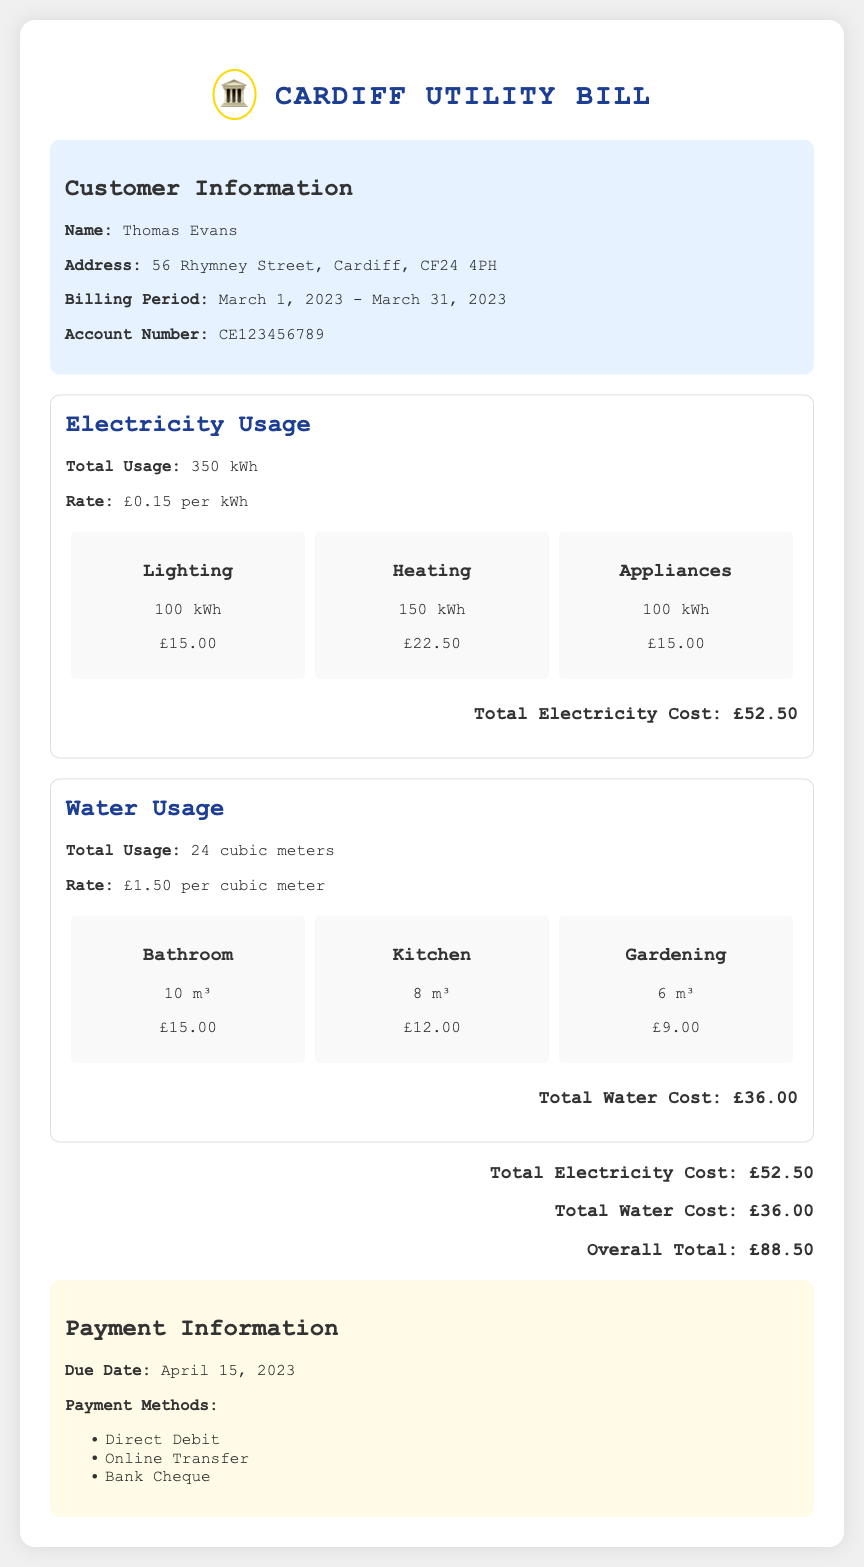What is the name of the customer? The document states the customer's name is Thomas Evans.
Answer: Thomas Evans What is the address of the residence? The address provided in the document is essential for billing purposes; it mentions 56 Rhymney Street, Cardiff, CF24 4PH.
Answer: 56 Rhymney Street, Cardiff, CF24 4PH What is the total electricity usage for March 2023? The total electricity usage is directly mentioned in the electricity section of the document as 350 kWh.
Answer: 350 kWh What is the total water usage? The document lists the total water usage, stating it's 24 cubic meters.
Answer: 24 cubic meters What is the due date for the payment? The due date is stated under the payment information section, which is April 15, 2023.
Answer: April 15, 2023 What is the total cost for water? The document explicitly states the total cost for water as £36.00.
Answer: £36.00 How much is charged per cubic meter of water? The rate for water usage is indicated in the document as £1.50 per cubic meter.
Answer: £1.50 What is the overall total bill amount? The overall total is calculated by adding the electricity and water costs, which is stated as £88.50.
Answer: £88.50 What are the available payment methods? The document lists the payment methods, which include Direct Debit, Online Transfer, and Bank Cheque.
Answer: Direct Debit, Online Transfer, Bank Cheque 